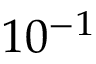Convert formula to latex. <formula><loc_0><loc_0><loc_500><loc_500>1 0 ^ { - 1 }</formula> 